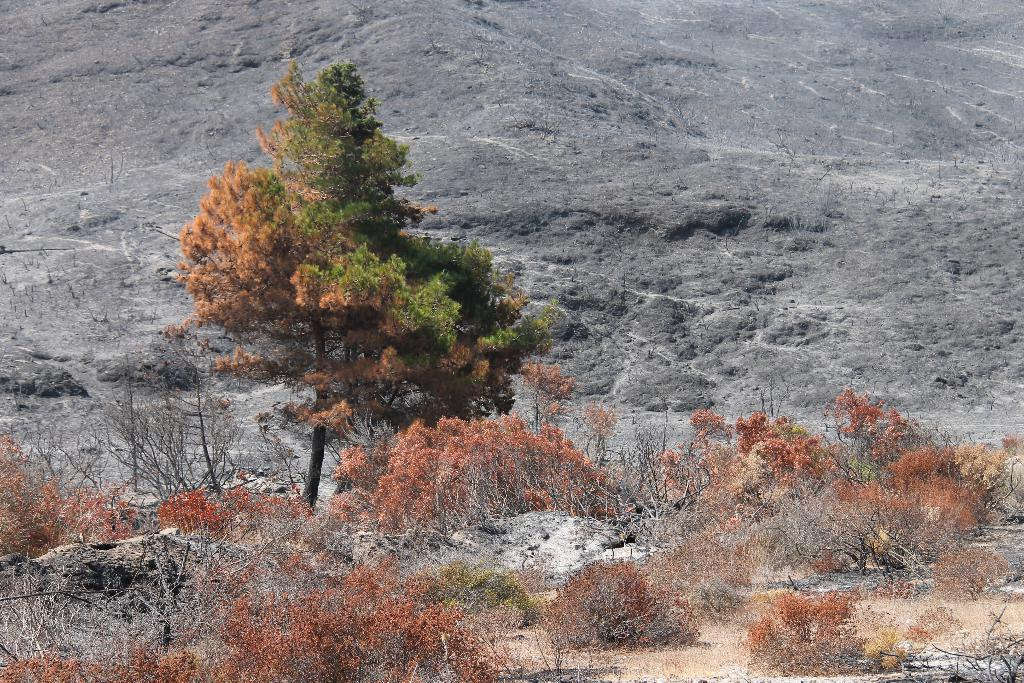What type of vegetation is in the foreground of the image? There are bushes in the foreground of the image. What other types of vegetation can be seen in the image? There are trees visible in the image. What geographical feature is in the background of the image? There is a hill in the background of the image. What type of lawyer is visible in the image? There is no lawyer present in the image. What type of air is depicted in the image? There is no air depicted in the image; it is a photograph of a landscape. 